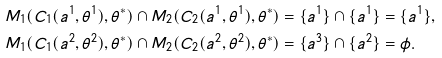<formula> <loc_0><loc_0><loc_500><loc_500>& M _ { 1 } ( C _ { 1 } ( a ^ { 1 } , \theta ^ { 1 } ) , \theta ^ { * } ) \cap M _ { 2 } ( C _ { 2 } ( a ^ { 1 } , \theta ^ { 1 } ) , \theta ^ { * } ) = \{ a ^ { 1 } \} \cap \{ a ^ { 1 } \} = \{ a ^ { 1 } \} , \\ & M _ { 1 } ( C _ { 1 } ( a ^ { 2 } , \theta ^ { 2 } ) , \theta ^ { * } ) \cap M _ { 2 } ( C _ { 2 } ( a ^ { 2 } , \theta ^ { 2 } ) , \theta ^ { * } ) = \{ a ^ { 3 } \} \cap \{ a ^ { 2 } \} = \phi .</formula> 